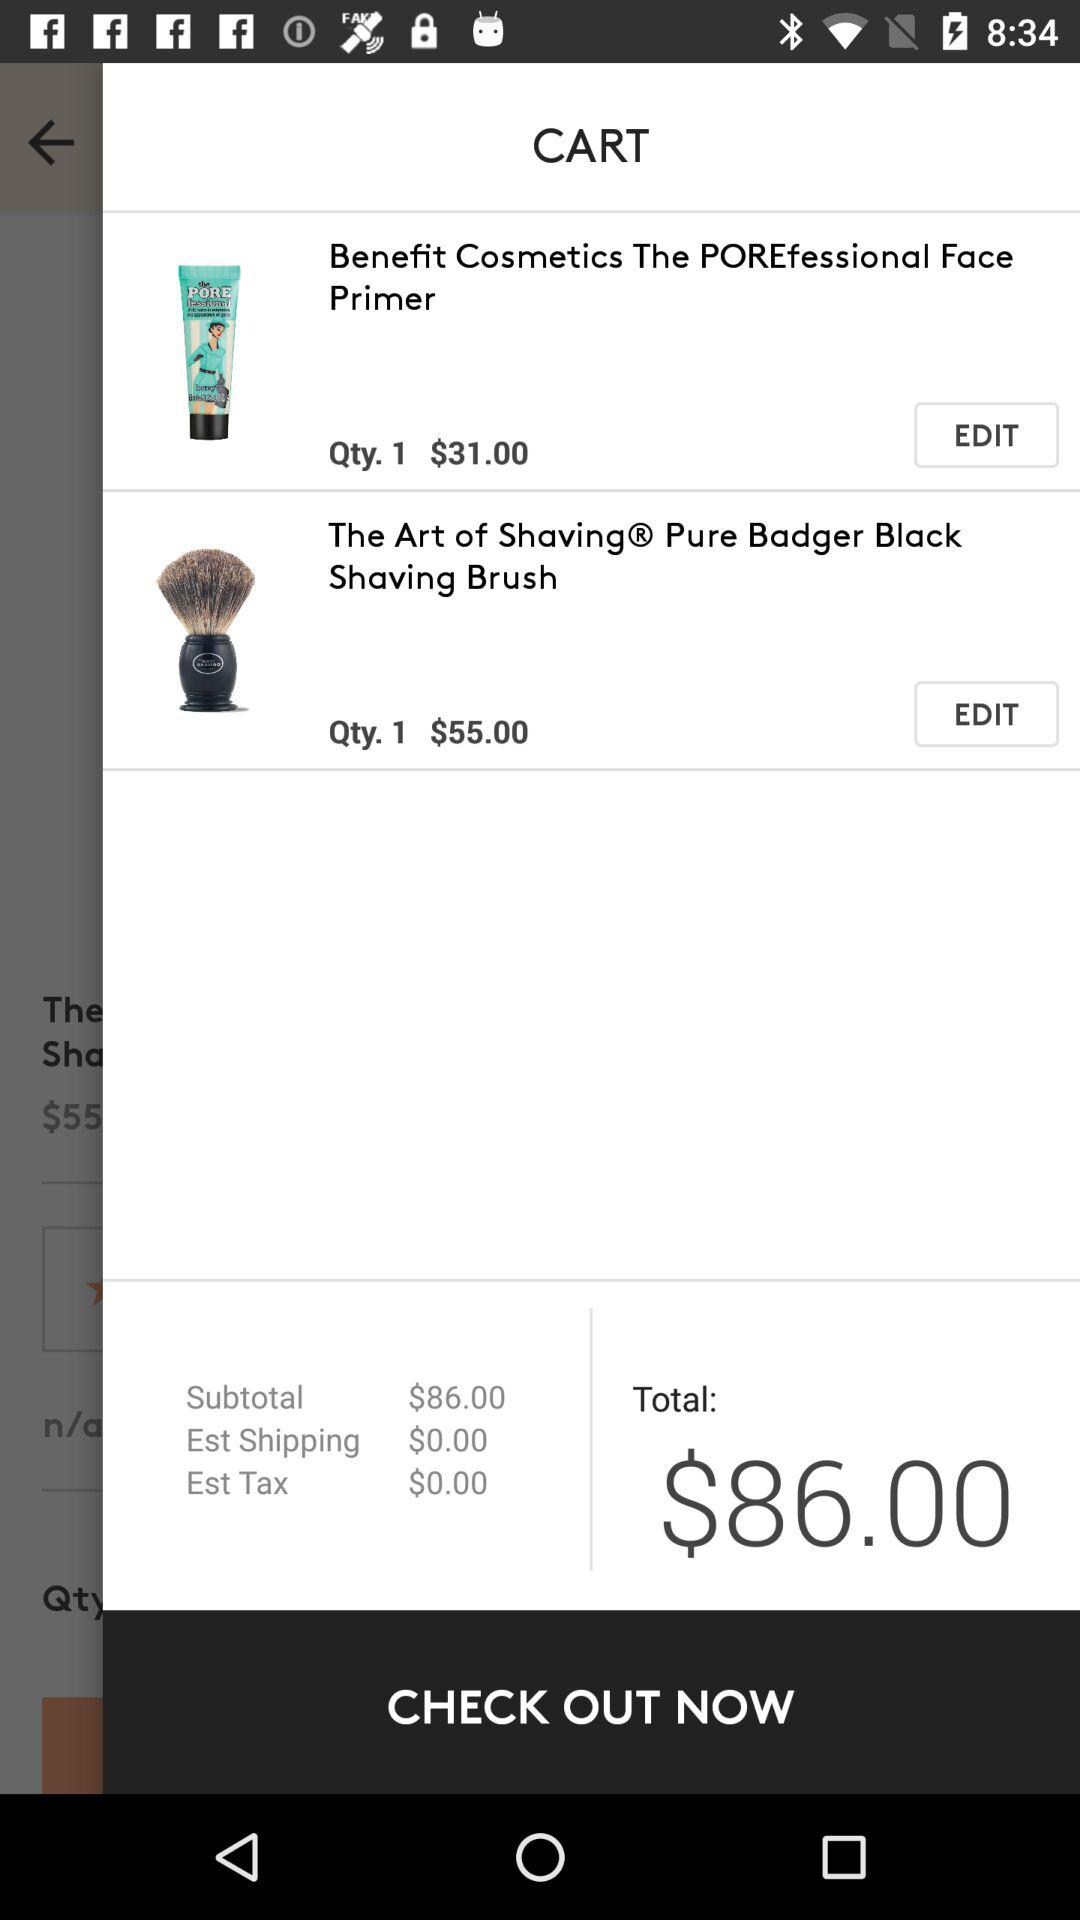How many items are in the cart?
Answer the question using a single word or phrase. 2 